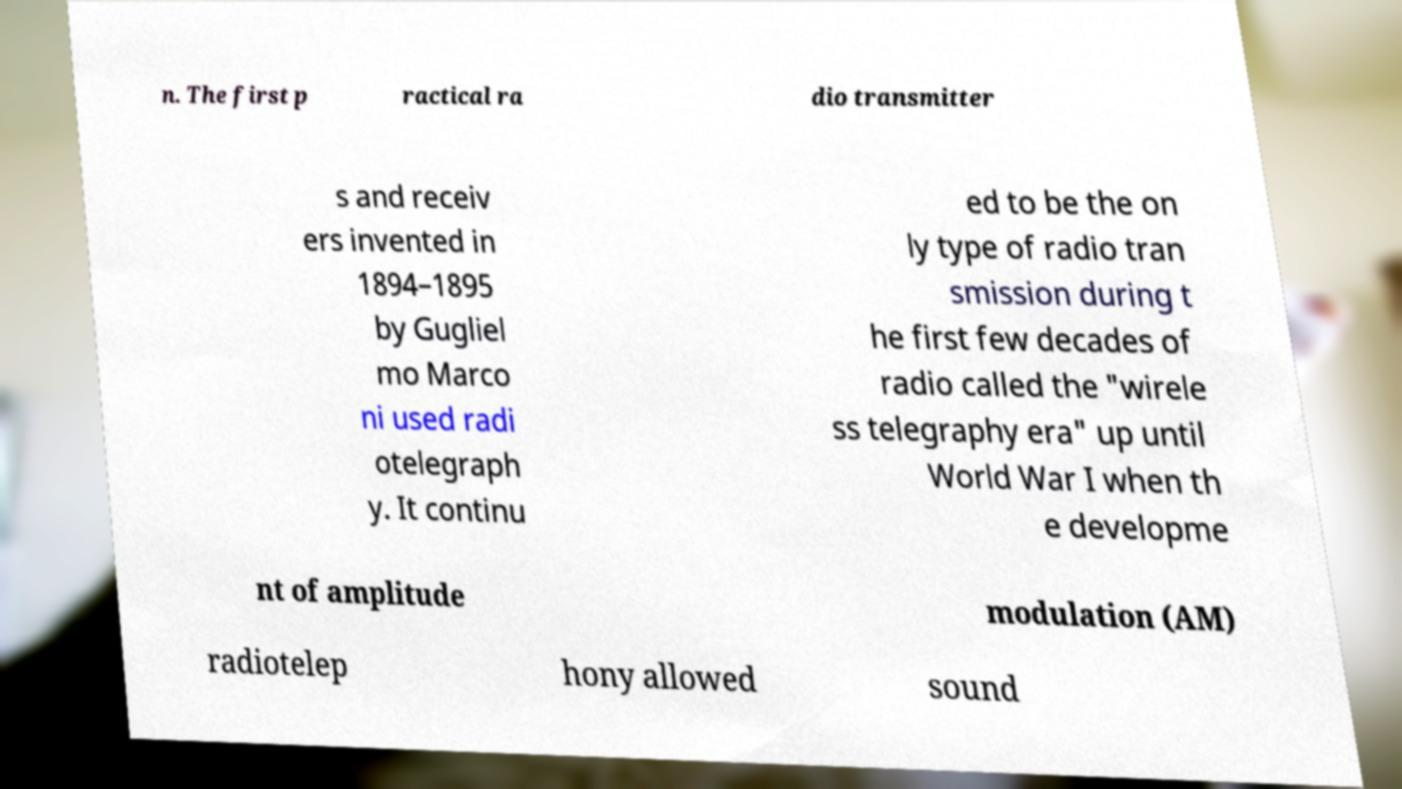What messages or text are displayed in this image? I need them in a readable, typed format. n. The first p ractical ra dio transmitter s and receiv ers invented in 1894–1895 by Gugliel mo Marco ni used radi otelegraph y. It continu ed to be the on ly type of radio tran smission during t he first few decades of radio called the "wirele ss telegraphy era" up until World War I when th e developme nt of amplitude modulation (AM) radiotelep hony allowed sound 